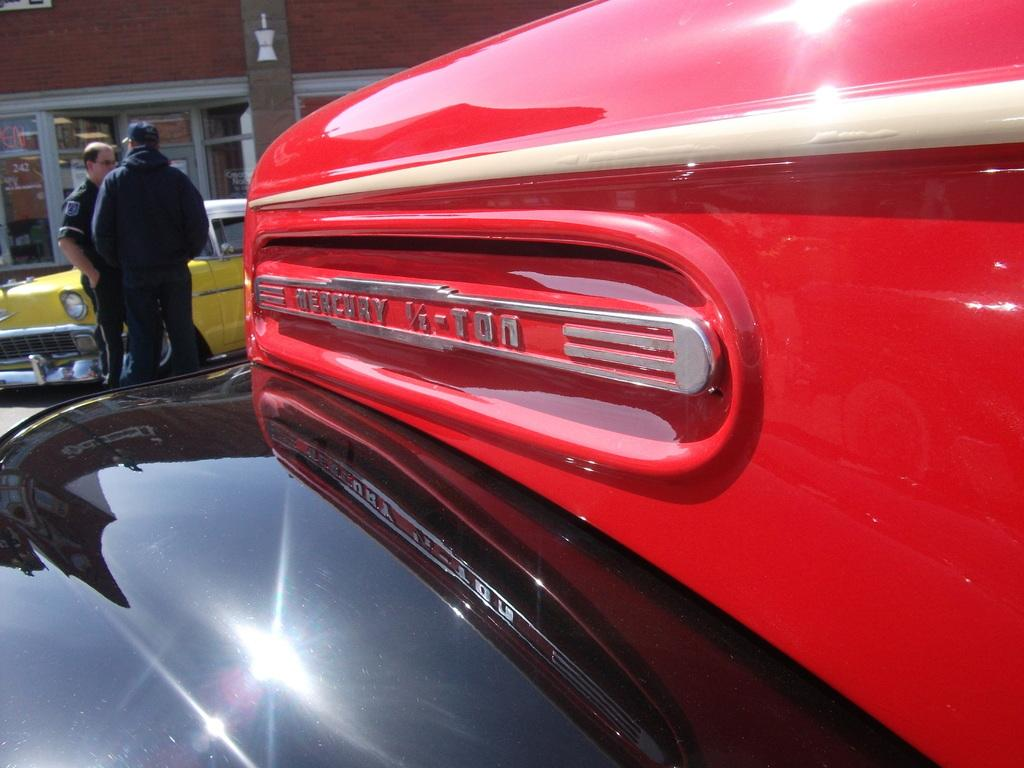<image>
Share a concise interpretation of the image provided. An updated car fender from an old Mercury shines in the sun. 